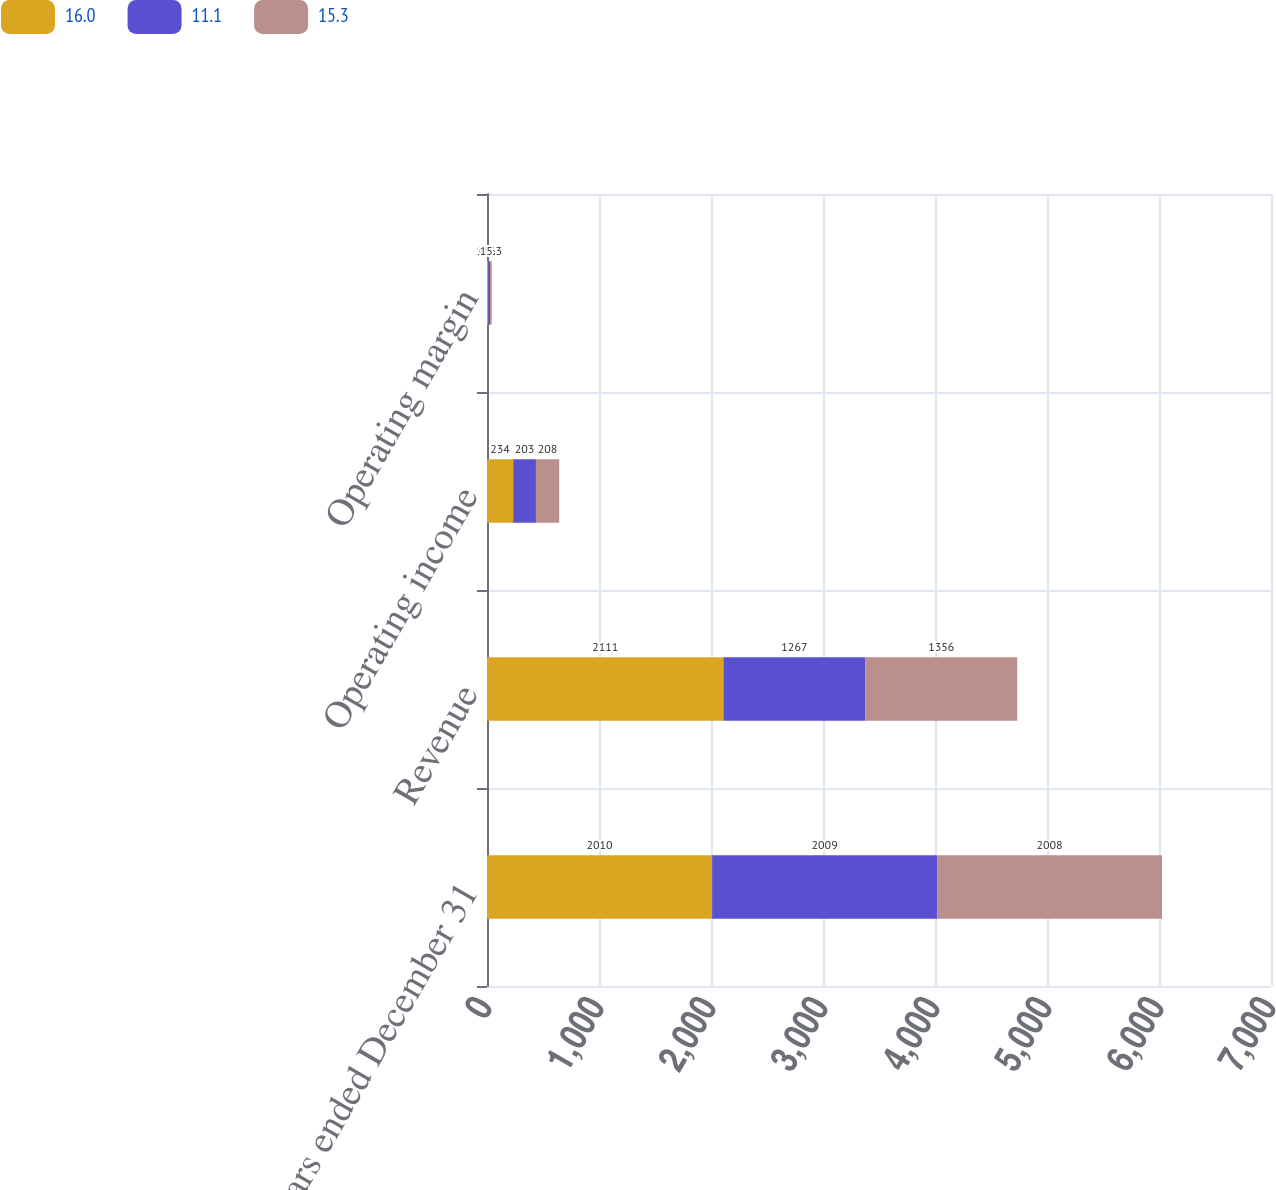<chart> <loc_0><loc_0><loc_500><loc_500><stacked_bar_chart><ecel><fcel>Years ended December 31<fcel>Revenue<fcel>Operating income<fcel>Operating margin<nl><fcel>16<fcel>2010<fcel>2111<fcel>234<fcel>11.1<nl><fcel>11.1<fcel>2009<fcel>1267<fcel>203<fcel>16<nl><fcel>15.3<fcel>2008<fcel>1356<fcel>208<fcel>15.3<nl></chart> 